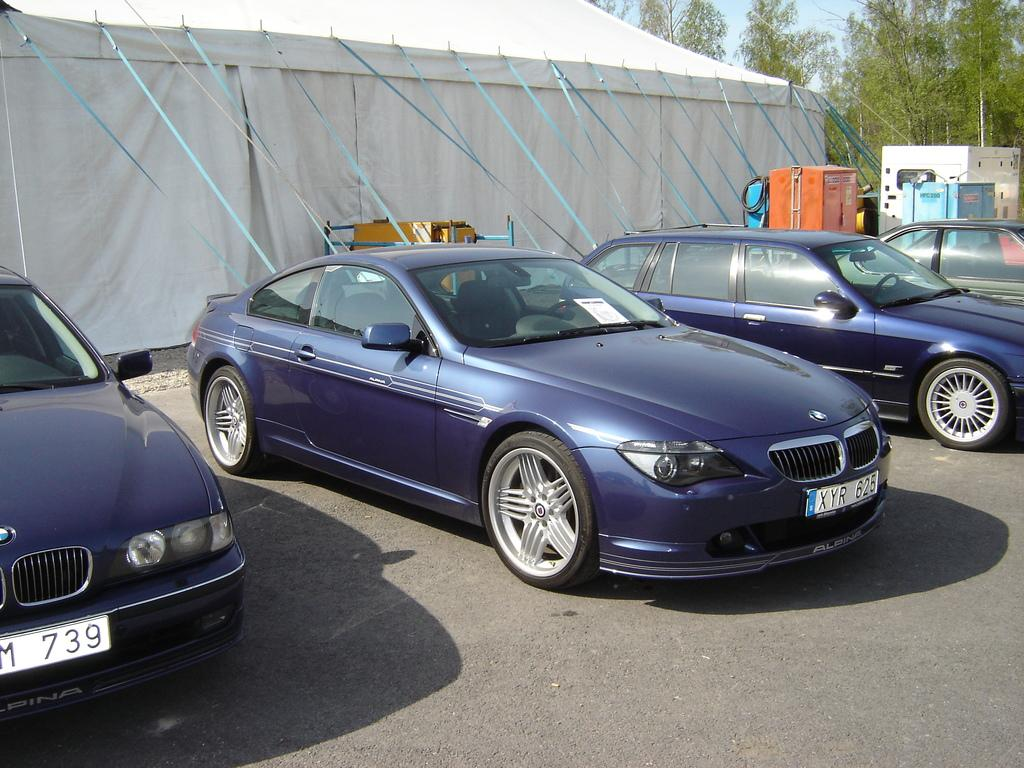What type of vehicles can be seen on the road in the image? There are cars on the road in the image. What can be seen in the background of the image? There is a tent, trees, and a generator in the background of the image. How many giraffes are visible in the image? There are no giraffes present in the image. What type of team is working on the generator in the image? There is no team visible in the image, nor is there any indication that a team is working on the generator. 